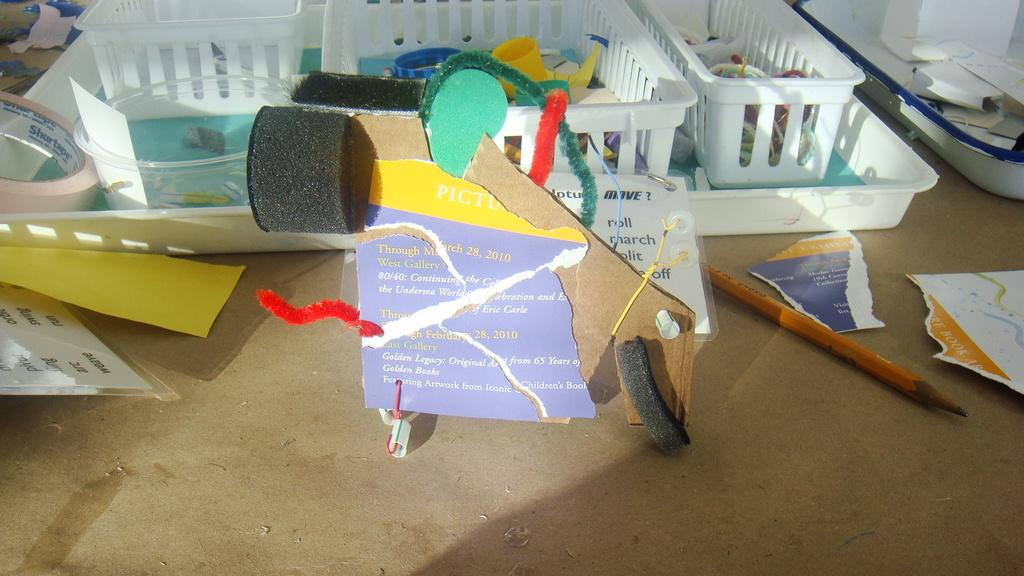What type of surface is visible in the image? There is a wooden surface in the image. What items are placed on the wooden surface? Papers, cardboard, a pencil, trays, containers, and a tape are present on the wooden surface. How many items can be seen on the wooden surface? There are at least seven items visible on the wooden surface. Can you see a bike performing magic tricks on the wooden surface in the image? No, there is no bike or magic tricks present in the image. The wooden surface contains papers, cardboard, a pencil, trays, containers, and a tape. 